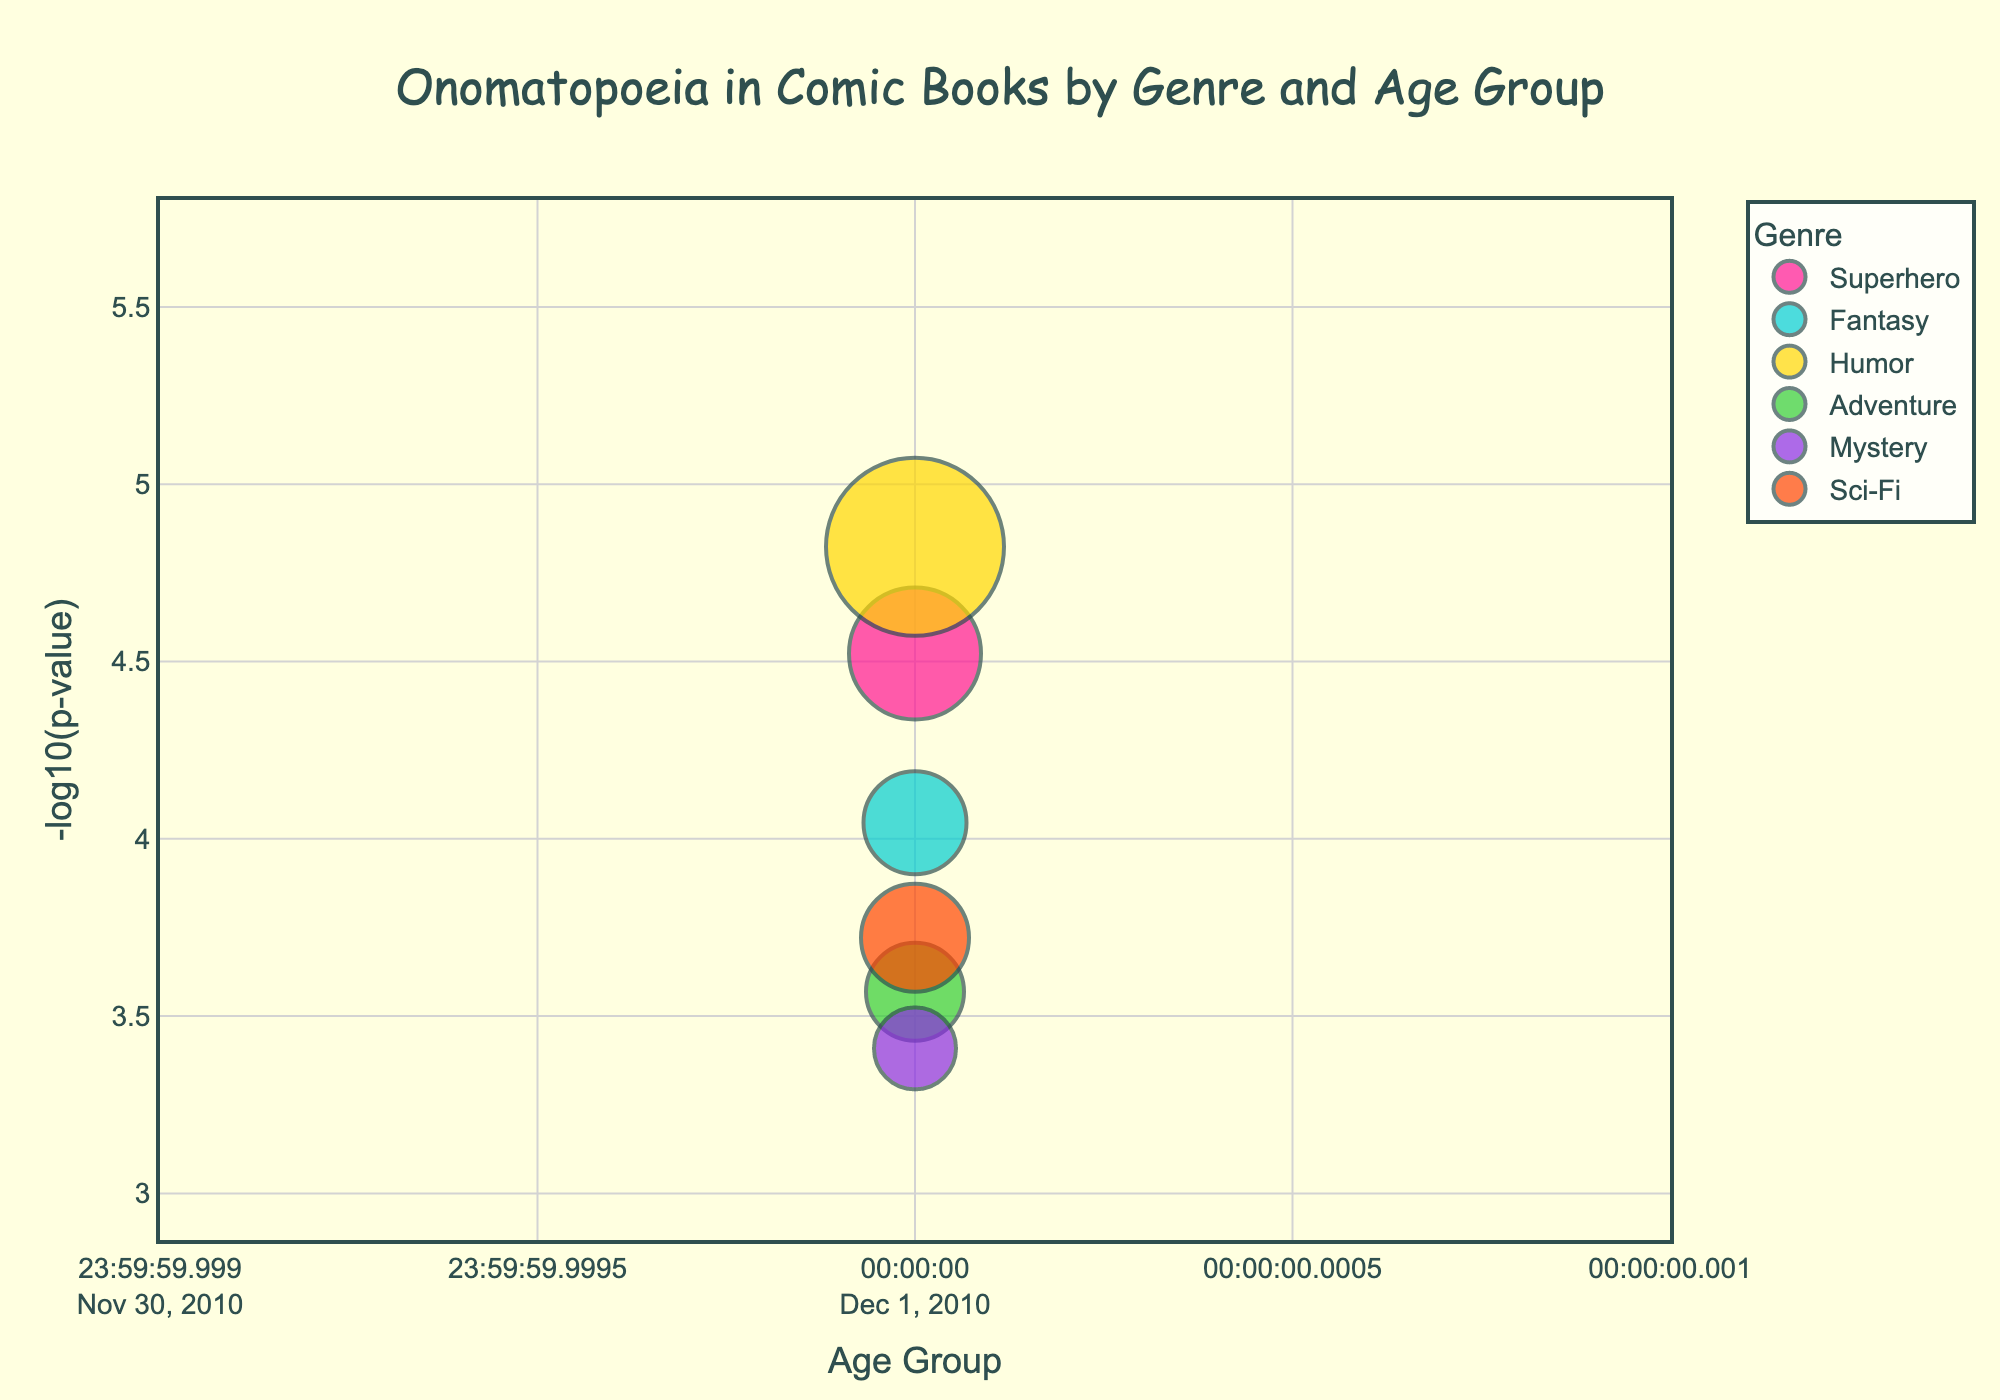Which genre has the highest -log10(p-value) for age group 6-9? First, identify the genre with the highest -log10(p-value) for the 6-9 age group by looking for the tallest marker in that age group. Humor has the highest -log10(p-value) among the markers for 6-9.
Answer: Humor How many genres are represented in the plot? Count the number of unique genres shown in the figure's legend. The genres are Superhero, Fantasy, Humor, Adventure, Mystery, and Sci-Fi.
Answer: Six Which age group has the highest number of onomatopoeia words in Superhero comics? Check the marker size for each age group within the Superhero genre. The largest marker size within the Superhero genre indicates the highest count, which is in age group 6-9.
Answer: 6-9 What is the -log10(p-value) for Mystery comics in the age group 13-16? Locate the marker for Mystery comics in the 13-16 age group and read its -log10(p-value) value from the y-axis. The -log10(p-value) for this marker is close to 0.12.
Answer: 0.12 Compare the count of onomatopoeia words in Humor comics between age groups 6-9 and 13-16. Which age group has a higher count? Compare the marker sizes for Humor comics in the 6-9 and 13-16 age groups. The 6-9 group has a larger marker size, indicating a higher count.
Answer: 6-9 For Adventure comics, what is the difference in -log10(p-value) between the 6-9 and 13-16 age groups? Locate the markers for Adventure comics in the 6-9 and 13-16 age groups and subtract the -log10(p-value) of the 13-16 group from that of the 6-9 group. The values are approximately 0.75 and 0.32 respectively, so the difference is about 0.43.
Answer: 0.43 Which genre has the lowest count of onomatopoeia words in the 10-12 age group? Look for the smallest marker size within the 10-12 age group across all genres. Mystery has the smallest marker, indicating the lowest count.
Answer: Mystery What is the average -log10(p-value) for Superhero comics across all age groups? Identify the -log10(p-value) values for Superhero comics in all age groups (6-9, 10-12, 13-16), which are approximately 5, 4.52, and 3.92. Calculate their average: (5 + 4.52 + 3.92) / 3.
Answer: 4.48 